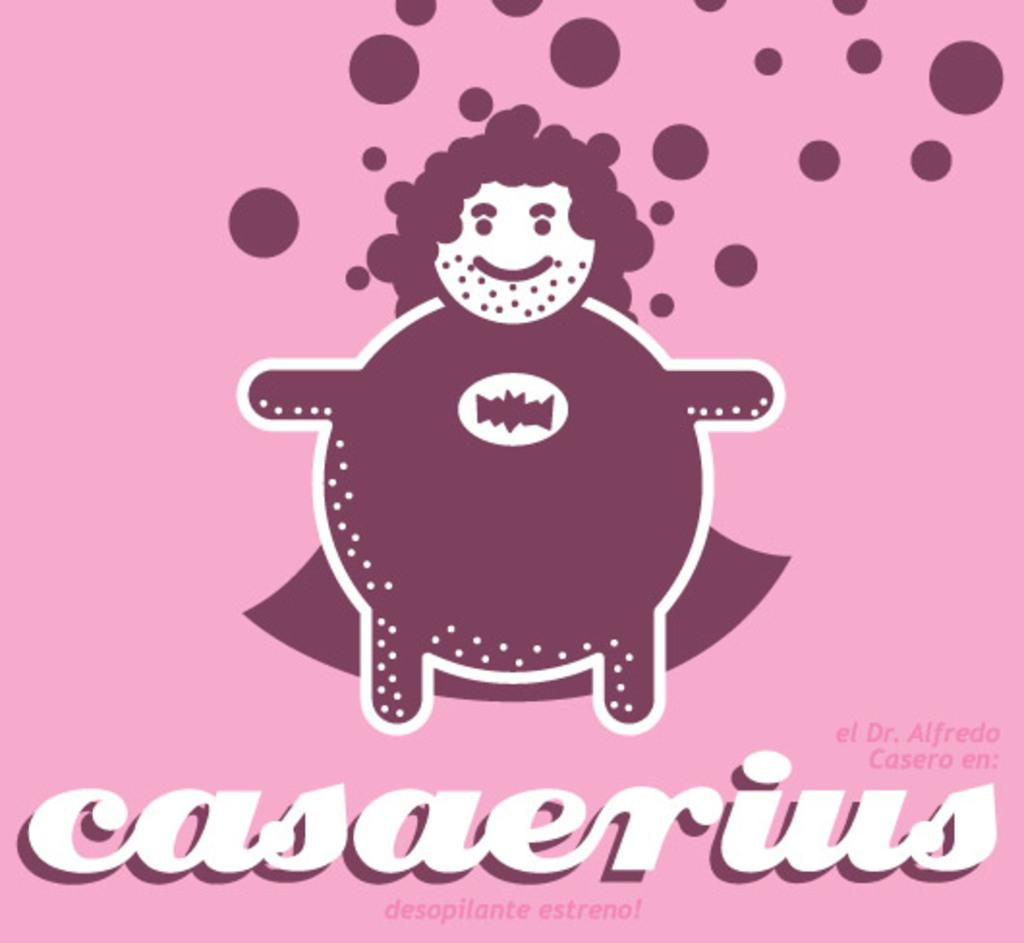<image>
Share a concise interpretation of the image provided. A drawing of a person wearing a cape and the word "casaerius" written beneath. 